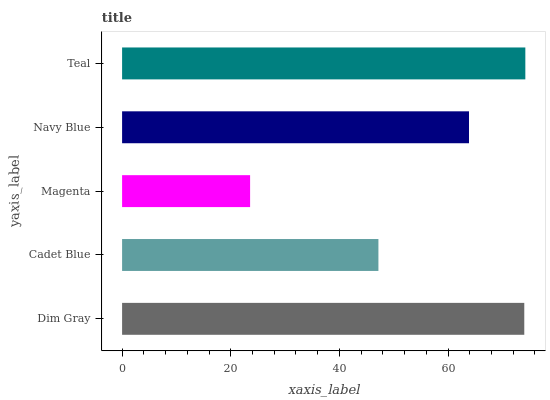Is Magenta the minimum?
Answer yes or no. Yes. Is Teal the maximum?
Answer yes or no. Yes. Is Cadet Blue the minimum?
Answer yes or no. No. Is Cadet Blue the maximum?
Answer yes or no. No. Is Dim Gray greater than Cadet Blue?
Answer yes or no. Yes. Is Cadet Blue less than Dim Gray?
Answer yes or no. Yes. Is Cadet Blue greater than Dim Gray?
Answer yes or no. No. Is Dim Gray less than Cadet Blue?
Answer yes or no. No. Is Navy Blue the high median?
Answer yes or no. Yes. Is Navy Blue the low median?
Answer yes or no. Yes. Is Cadet Blue the high median?
Answer yes or no. No. Is Teal the low median?
Answer yes or no. No. 